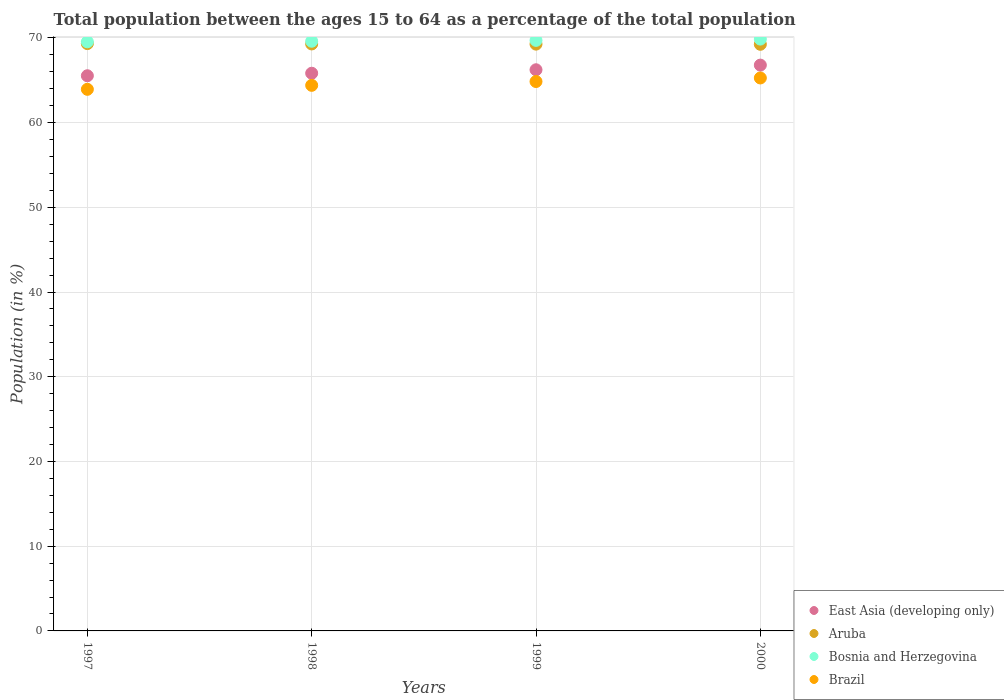How many different coloured dotlines are there?
Make the answer very short. 4. Is the number of dotlines equal to the number of legend labels?
Provide a short and direct response. Yes. What is the percentage of the population ages 15 to 64 in East Asia (developing only) in 1998?
Offer a terse response. 65.83. Across all years, what is the maximum percentage of the population ages 15 to 64 in Bosnia and Herzegovina?
Make the answer very short. 69.86. Across all years, what is the minimum percentage of the population ages 15 to 64 in East Asia (developing only)?
Provide a succinct answer. 65.53. In which year was the percentage of the population ages 15 to 64 in East Asia (developing only) maximum?
Offer a terse response. 2000. What is the total percentage of the population ages 15 to 64 in Brazil in the graph?
Your answer should be compact. 258.44. What is the difference between the percentage of the population ages 15 to 64 in Brazil in 1997 and that in 1998?
Ensure brevity in your answer.  -0.47. What is the difference between the percentage of the population ages 15 to 64 in Brazil in 1997 and the percentage of the population ages 15 to 64 in East Asia (developing only) in 2000?
Keep it short and to the point. -2.86. What is the average percentage of the population ages 15 to 64 in Aruba per year?
Provide a succinct answer. 69.28. In the year 1998, what is the difference between the percentage of the population ages 15 to 64 in East Asia (developing only) and percentage of the population ages 15 to 64 in Aruba?
Your answer should be very brief. -3.46. What is the ratio of the percentage of the population ages 15 to 64 in Brazil in 1997 to that in 2000?
Offer a terse response. 0.98. Is the percentage of the population ages 15 to 64 in Bosnia and Herzegovina in 1998 less than that in 1999?
Provide a short and direct response. Yes. Is the difference between the percentage of the population ages 15 to 64 in East Asia (developing only) in 1997 and 2000 greater than the difference between the percentage of the population ages 15 to 64 in Aruba in 1997 and 2000?
Keep it short and to the point. No. What is the difference between the highest and the second highest percentage of the population ages 15 to 64 in Bosnia and Herzegovina?
Offer a very short reply. 0.15. What is the difference between the highest and the lowest percentage of the population ages 15 to 64 in Bosnia and Herzegovina?
Offer a terse response. 0.32. In how many years, is the percentage of the population ages 15 to 64 in East Asia (developing only) greater than the average percentage of the population ages 15 to 64 in East Asia (developing only) taken over all years?
Provide a short and direct response. 2. Is it the case that in every year, the sum of the percentage of the population ages 15 to 64 in Aruba and percentage of the population ages 15 to 64 in East Asia (developing only)  is greater than the sum of percentage of the population ages 15 to 64 in Bosnia and Herzegovina and percentage of the population ages 15 to 64 in Brazil?
Provide a succinct answer. No. Is it the case that in every year, the sum of the percentage of the population ages 15 to 64 in East Asia (developing only) and percentage of the population ages 15 to 64 in Bosnia and Herzegovina  is greater than the percentage of the population ages 15 to 64 in Aruba?
Provide a short and direct response. Yes. Is the percentage of the population ages 15 to 64 in Aruba strictly less than the percentage of the population ages 15 to 64 in Bosnia and Herzegovina over the years?
Your answer should be compact. Yes. What is the difference between two consecutive major ticks on the Y-axis?
Your response must be concise. 10. Are the values on the major ticks of Y-axis written in scientific E-notation?
Provide a succinct answer. No. Does the graph contain any zero values?
Provide a short and direct response. No. How many legend labels are there?
Give a very brief answer. 4. What is the title of the graph?
Provide a succinct answer. Total population between the ages 15 to 64 as a percentage of the total population. What is the label or title of the Y-axis?
Ensure brevity in your answer.  Population (in %). What is the Population (in %) of East Asia (developing only) in 1997?
Offer a very short reply. 65.53. What is the Population (in %) of Aruba in 1997?
Your answer should be very brief. 69.33. What is the Population (in %) in Bosnia and Herzegovina in 1997?
Provide a succinct answer. 69.53. What is the Population (in %) of Brazil in 1997?
Your response must be concise. 63.93. What is the Population (in %) in East Asia (developing only) in 1998?
Your answer should be compact. 65.83. What is the Population (in %) of Aruba in 1998?
Provide a short and direct response. 69.28. What is the Population (in %) in Bosnia and Herzegovina in 1998?
Ensure brevity in your answer.  69.6. What is the Population (in %) in Brazil in 1998?
Provide a short and direct response. 64.4. What is the Population (in %) in East Asia (developing only) in 1999?
Make the answer very short. 66.24. What is the Population (in %) of Aruba in 1999?
Provide a short and direct response. 69.26. What is the Population (in %) in Bosnia and Herzegovina in 1999?
Give a very brief answer. 69.7. What is the Population (in %) of Brazil in 1999?
Your response must be concise. 64.85. What is the Population (in %) in East Asia (developing only) in 2000?
Offer a terse response. 66.79. What is the Population (in %) in Aruba in 2000?
Give a very brief answer. 69.24. What is the Population (in %) in Bosnia and Herzegovina in 2000?
Offer a very short reply. 69.86. What is the Population (in %) in Brazil in 2000?
Ensure brevity in your answer.  65.27. Across all years, what is the maximum Population (in %) in East Asia (developing only)?
Make the answer very short. 66.79. Across all years, what is the maximum Population (in %) of Aruba?
Ensure brevity in your answer.  69.33. Across all years, what is the maximum Population (in %) in Bosnia and Herzegovina?
Your answer should be compact. 69.86. Across all years, what is the maximum Population (in %) in Brazil?
Your answer should be very brief. 65.27. Across all years, what is the minimum Population (in %) of East Asia (developing only)?
Offer a very short reply. 65.53. Across all years, what is the minimum Population (in %) of Aruba?
Provide a succinct answer. 69.24. Across all years, what is the minimum Population (in %) of Bosnia and Herzegovina?
Your answer should be very brief. 69.53. Across all years, what is the minimum Population (in %) in Brazil?
Make the answer very short. 63.93. What is the total Population (in %) in East Asia (developing only) in the graph?
Provide a succinct answer. 264.38. What is the total Population (in %) of Aruba in the graph?
Your answer should be compact. 277.11. What is the total Population (in %) in Bosnia and Herzegovina in the graph?
Your answer should be very brief. 278.7. What is the total Population (in %) in Brazil in the graph?
Give a very brief answer. 258.44. What is the difference between the Population (in %) in East Asia (developing only) in 1997 and that in 1998?
Provide a short and direct response. -0.3. What is the difference between the Population (in %) in Aruba in 1997 and that in 1998?
Your answer should be compact. 0.04. What is the difference between the Population (in %) of Bosnia and Herzegovina in 1997 and that in 1998?
Keep it short and to the point. -0.07. What is the difference between the Population (in %) in Brazil in 1997 and that in 1998?
Your response must be concise. -0.47. What is the difference between the Population (in %) in East Asia (developing only) in 1997 and that in 1999?
Offer a terse response. -0.71. What is the difference between the Population (in %) of Aruba in 1997 and that in 1999?
Offer a terse response. 0.06. What is the difference between the Population (in %) in Bosnia and Herzegovina in 1997 and that in 1999?
Provide a short and direct response. -0.17. What is the difference between the Population (in %) in Brazil in 1997 and that in 1999?
Your answer should be compact. -0.92. What is the difference between the Population (in %) of East Asia (developing only) in 1997 and that in 2000?
Provide a succinct answer. -1.26. What is the difference between the Population (in %) of Aruba in 1997 and that in 2000?
Your answer should be very brief. 0.08. What is the difference between the Population (in %) of Bosnia and Herzegovina in 1997 and that in 2000?
Keep it short and to the point. -0.32. What is the difference between the Population (in %) in Brazil in 1997 and that in 2000?
Provide a succinct answer. -1.34. What is the difference between the Population (in %) in East Asia (developing only) in 1998 and that in 1999?
Provide a succinct answer. -0.41. What is the difference between the Population (in %) of Aruba in 1998 and that in 1999?
Offer a terse response. 0.02. What is the difference between the Population (in %) in Bosnia and Herzegovina in 1998 and that in 1999?
Provide a succinct answer. -0.1. What is the difference between the Population (in %) in Brazil in 1998 and that in 1999?
Make the answer very short. -0.45. What is the difference between the Population (in %) of East Asia (developing only) in 1998 and that in 2000?
Ensure brevity in your answer.  -0.96. What is the difference between the Population (in %) in Aruba in 1998 and that in 2000?
Offer a very short reply. 0.04. What is the difference between the Population (in %) in Bosnia and Herzegovina in 1998 and that in 2000?
Offer a terse response. -0.25. What is the difference between the Population (in %) in Brazil in 1998 and that in 2000?
Offer a terse response. -0.87. What is the difference between the Population (in %) in East Asia (developing only) in 1999 and that in 2000?
Offer a very short reply. -0.55. What is the difference between the Population (in %) of Aruba in 1999 and that in 2000?
Your answer should be very brief. 0.02. What is the difference between the Population (in %) of Bosnia and Herzegovina in 1999 and that in 2000?
Your response must be concise. -0.15. What is the difference between the Population (in %) in Brazil in 1999 and that in 2000?
Give a very brief answer. -0.42. What is the difference between the Population (in %) in East Asia (developing only) in 1997 and the Population (in %) in Aruba in 1998?
Give a very brief answer. -3.75. What is the difference between the Population (in %) of East Asia (developing only) in 1997 and the Population (in %) of Bosnia and Herzegovina in 1998?
Your response must be concise. -4.07. What is the difference between the Population (in %) in East Asia (developing only) in 1997 and the Population (in %) in Brazil in 1998?
Provide a short and direct response. 1.13. What is the difference between the Population (in %) in Aruba in 1997 and the Population (in %) in Bosnia and Herzegovina in 1998?
Offer a very short reply. -0.28. What is the difference between the Population (in %) of Aruba in 1997 and the Population (in %) of Brazil in 1998?
Your answer should be very brief. 4.93. What is the difference between the Population (in %) of Bosnia and Herzegovina in 1997 and the Population (in %) of Brazil in 1998?
Keep it short and to the point. 5.14. What is the difference between the Population (in %) in East Asia (developing only) in 1997 and the Population (in %) in Aruba in 1999?
Give a very brief answer. -3.73. What is the difference between the Population (in %) in East Asia (developing only) in 1997 and the Population (in %) in Bosnia and Herzegovina in 1999?
Keep it short and to the point. -4.17. What is the difference between the Population (in %) in East Asia (developing only) in 1997 and the Population (in %) in Brazil in 1999?
Keep it short and to the point. 0.68. What is the difference between the Population (in %) in Aruba in 1997 and the Population (in %) in Bosnia and Herzegovina in 1999?
Your answer should be very brief. -0.38. What is the difference between the Population (in %) in Aruba in 1997 and the Population (in %) in Brazil in 1999?
Offer a terse response. 4.48. What is the difference between the Population (in %) in Bosnia and Herzegovina in 1997 and the Population (in %) in Brazil in 1999?
Offer a very short reply. 4.69. What is the difference between the Population (in %) of East Asia (developing only) in 1997 and the Population (in %) of Aruba in 2000?
Keep it short and to the point. -3.71. What is the difference between the Population (in %) in East Asia (developing only) in 1997 and the Population (in %) in Bosnia and Herzegovina in 2000?
Your answer should be very brief. -4.33. What is the difference between the Population (in %) in East Asia (developing only) in 1997 and the Population (in %) in Brazil in 2000?
Provide a short and direct response. 0.26. What is the difference between the Population (in %) in Aruba in 1997 and the Population (in %) in Bosnia and Herzegovina in 2000?
Offer a very short reply. -0.53. What is the difference between the Population (in %) in Aruba in 1997 and the Population (in %) in Brazil in 2000?
Offer a terse response. 4.06. What is the difference between the Population (in %) in Bosnia and Herzegovina in 1997 and the Population (in %) in Brazil in 2000?
Make the answer very short. 4.27. What is the difference between the Population (in %) in East Asia (developing only) in 1998 and the Population (in %) in Aruba in 1999?
Keep it short and to the point. -3.44. What is the difference between the Population (in %) of East Asia (developing only) in 1998 and the Population (in %) of Bosnia and Herzegovina in 1999?
Provide a short and direct response. -3.88. What is the difference between the Population (in %) in Aruba in 1998 and the Population (in %) in Bosnia and Herzegovina in 1999?
Give a very brief answer. -0.42. What is the difference between the Population (in %) in Aruba in 1998 and the Population (in %) in Brazil in 1999?
Provide a short and direct response. 4.44. What is the difference between the Population (in %) of Bosnia and Herzegovina in 1998 and the Population (in %) of Brazil in 1999?
Offer a very short reply. 4.75. What is the difference between the Population (in %) of East Asia (developing only) in 1998 and the Population (in %) of Aruba in 2000?
Your response must be concise. -3.42. What is the difference between the Population (in %) in East Asia (developing only) in 1998 and the Population (in %) in Bosnia and Herzegovina in 2000?
Offer a terse response. -4.03. What is the difference between the Population (in %) in East Asia (developing only) in 1998 and the Population (in %) in Brazil in 2000?
Offer a terse response. 0.56. What is the difference between the Population (in %) of Aruba in 1998 and the Population (in %) of Bosnia and Herzegovina in 2000?
Your answer should be very brief. -0.57. What is the difference between the Population (in %) in Aruba in 1998 and the Population (in %) in Brazil in 2000?
Your answer should be very brief. 4.02. What is the difference between the Population (in %) of Bosnia and Herzegovina in 1998 and the Population (in %) of Brazil in 2000?
Your response must be concise. 4.33. What is the difference between the Population (in %) of East Asia (developing only) in 1999 and the Population (in %) of Aruba in 2000?
Give a very brief answer. -3.01. What is the difference between the Population (in %) of East Asia (developing only) in 1999 and the Population (in %) of Bosnia and Herzegovina in 2000?
Your answer should be compact. -3.62. What is the difference between the Population (in %) of Aruba in 1999 and the Population (in %) of Bosnia and Herzegovina in 2000?
Offer a very short reply. -0.6. What is the difference between the Population (in %) in Aruba in 1999 and the Population (in %) in Brazil in 2000?
Ensure brevity in your answer.  3.99. What is the difference between the Population (in %) of Bosnia and Herzegovina in 1999 and the Population (in %) of Brazil in 2000?
Your response must be concise. 4.44. What is the average Population (in %) in East Asia (developing only) per year?
Your answer should be very brief. 66.09. What is the average Population (in %) of Aruba per year?
Your answer should be very brief. 69.28. What is the average Population (in %) in Bosnia and Herzegovina per year?
Keep it short and to the point. 69.67. What is the average Population (in %) of Brazil per year?
Your response must be concise. 64.61. In the year 1997, what is the difference between the Population (in %) of East Asia (developing only) and Population (in %) of Aruba?
Make the answer very short. -3.8. In the year 1997, what is the difference between the Population (in %) of East Asia (developing only) and Population (in %) of Bosnia and Herzegovina?
Your answer should be very brief. -4.01. In the year 1997, what is the difference between the Population (in %) of East Asia (developing only) and Population (in %) of Brazil?
Give a very brief answer. 1.6. In the year 1997, what is the difference between the Population (in %) in Aruba and Population (in %) in Bosnia and Herzegovina?
Your answer should be compact. -0.21. In the year 1997, what is the difference between the Population (in %) of Aruba and Population (in %) of Brazil?
Offer a very short reply. 5.4. In the year 1997, what is the difference between the Population (in %) of Bosnia and Herzegovina and Population (in %) of Brazil?
Ensure brevity in your answer.  5.61. In the year 1998, what is the difference between the Population (in %) of East Asia (developing only) and Population (in %) of Aruba?
Your answer should be compact. -3.46. In the year 1998, what is the difference between the Population (in %) in East Asia (developing only) and Population (in %) in Bosnia and Herzegovina?
Ensure brevity in your answer.  -3.78. In the year 1998, what is the difference between the Population (in %) in East Asia (developing only) and Population (in %) in Brazil?
Your answer should be compact. 1.43. In the year 1998, what is the difference between the Population (in %) of Aruba and Population (in %) of Bosnia and Herzegovina?
Provide a succinct answer. -0.32. In the year 1998, what is the difference between the Population (in %) in Aruba and Population (in %) in Brazil?
Provide a succinct answer. 4.88. In the year 1998, what is the difference between the Population (in %) of Bosnia and Herzegovina and Population (in %) of Brazil?
Provide a short and direct response. 5.2. In the year 1999, what is the difference between the Population (in %) in East Asia (developing only) and Population (in %) in Aruba?
Your response must be concise. -3.03. In the year 1999, what is the difference between the Population (in %) of East Asia (developing only) and Population (in %) of Bosnia and Herzegovina?
Ensure brevity in your answer.  -3.47. In the year 1999, what is the difference between the Population (in %) in East Asia (developing only) and Population (in %) in Brazil?
Provide a succinct answer. 1.39. In the year 1999, what is the difference between the Population (in %) in Aruba and Population (in %) in Bosnia and Herzegovina?
Your response must be concise. -0.44. In the year 1999, what is the difference between the Population (in %) in Aruba and Population (in %) in Brazil?
Offer a very short reply. 4.41. In the year 1999, what is the difference between the Population (in %) of Bosnia and Herzegovina and Population (in %) of Brazil?
Offer a terse response. 4.86. In the year 2000, what is the difference between the Population (in %) of East Asia (developing only) and Population (in %) of Aruba?
Ensure brevity in your answer.  -2.46. In the year 2000, what is the difference between the Population (in %) in East Asia (developing only) and Population (in %) in Bosnia and Herzegovina?
Offer a very short reply. -3.07. In the year 2000, what is the difference between the Population (in %) in East Asia (developing only) and Population (in %) in Brazil?
Provide a short and direct response. 1.52. In the year 2000, what is the difference between the Population (in %) in Aruba and Population (in %) in Bosnia and Herzegovina?
Your answer should be very brief. -0.62. In the year 2000, what is the difference between the Population (in %) of Aruba and Population (in %) of Brazil?
Provide a short and direct response. 3.97. In the year 2000, what is the difference between the Population (in %) in Bosnia and Herzegovina and Population (in %) in Brazil?
Your response must be concise. 4.59. What is the ratio of the Population (in %) of East Asia (developing only) in 1997 to that in 1998?
Your answer should be very brief. 1. What is the ratio of the Population (in %) in East Asia (developing only) in 1997 to that in 1999?
Offer a very short reply. 0.99. What is the ratio of the Population (in %) of Brazil in 1997 to that in 1999?
Your answer should be very brief. 0.99. What is the ratio of the Population (in %) of East Asia (developing only) in 1997 to that in 2000?
Your response must be concise. 0.98. What is the ratio of the Population (in %) in Aruba in 1997 to that in 2000?
Provide a short and direct response. 1. What is the ratio of the Population (in %) of Brazil in 1997 to that in 2000?
Make the answer very short. 0.98. What is the ratio of the Population (in %) of Bosnia and Herzegovina in 1998 to that in 1999?
Offer a terse response. 1. What is the ratio of the Population (in %) of Brazil in 1998 to that in 1999?
Give a very brief answer. 0.99. What is the ratio of the Population (in %) of East Asia (developing only) in 1998 to that in 2000?
Make the answer very short. 0.99. What is the ratio of the Population (in %) of Brazil in 1998 to that in 2000?
Your answer should be compact. 0.99. What is the ratio of the Population (in %) of Bosnia and Herzegovina in 1999 to that in 2000?
Provide a succinct answer. 1. What is the difference between the highest and the second highest Population (in %) in East Asia (developing only)?
Your answer should be compact. 0.55. What is the difference between the highest and the second highest Population (in %) in Aruba?
Make the answer very short. 0.04. What is the difference between the highest and the second highest Population (in %) in Bosnia and Herzegovina?
Your answer should be very brief. 0.15. What is the difference between the highest and the second highest Population (in %) of Brazil?
Offer a very short reply. 0.42. What is the difference between the highest and the lowest Population (in %) in East Asia (developing only)?
Your answer should be compact. 1.26. What is the difference between the highest and the lowest Population (in %) of Aruba?
Provide a short and direct response. 0.08. What is the difference between the highest and the lowest Population (in %) in Bosnia and Herzegovina?
Your answer should be very brief. 0.32. What is the difference between the highest and the lowest Population (in %) of Brazil?
Offer a very short reply. 1.34. 